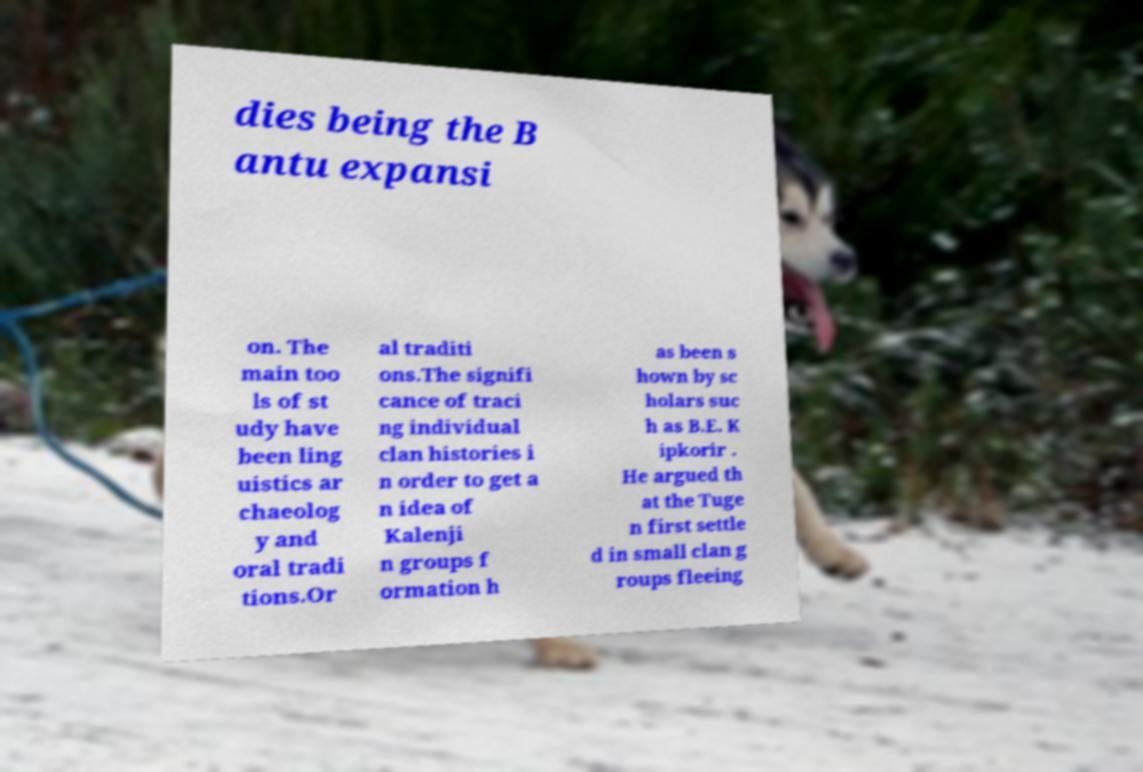Could you extract and type out the text from this image? dies being the B antu expansi on. The main too ls of st udy have been ling uistics ar chaeolog y and oral tradi tions.Or al traditi ons.The signifi cance of traci ng individual clan histories i n order to get a n idea of Kalenji n groups f ormation h as been s hown by sc holars suc h as B.E. K ipkorir . He argued th at the Tuge n first settle d in small clan g roups fleeing 